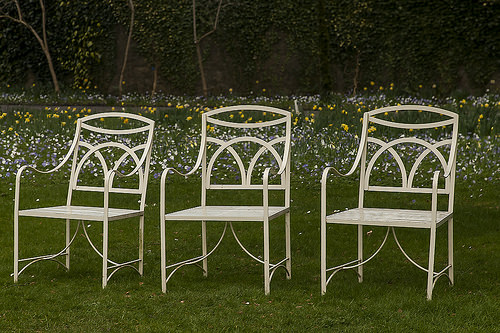<image>
Can you confirm if the chair is next to the chair? No. The chair is not positioned next to the chair. They are located in different areas of the scene. 